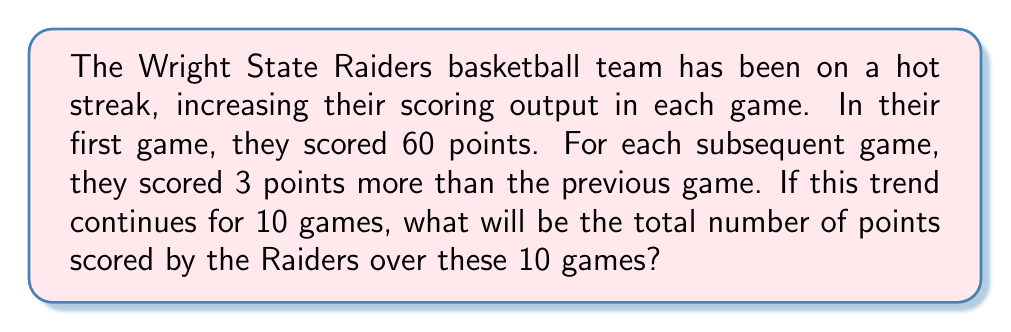Help me with this question. Let's approach this step-by-step using arithmetic sequences and series:

1) First, we identify that this is an arithmetic sequence with:
   - First term, $a_1 = 60$
   - Common difference, $d = 3$
   - Number of terms, $n = 10$

2) The arithmetic sequence formula is:
   $a_n = a_1 + (n-1)d$

3) We can find the 10th game score:
   $a_{10} = 60 + (10-1)3 = 60 + 27 = 87$

4) To find the total points, we need to sum this arithmetic sequence. The formula for the sum of an arithmetic sequence is:
   $$S_n = \frac{n}{2}(a_1 + a_n)$$

5) We know $n = 10$, $a_1 = 60$, and we calculated $a_{10} = 87$. Let's substitute:
   $$S_{10} = \frac{10}{2}(60 + 87)$$

6) Simplify:
   $$S_{10} = 5(147) = 735$$

Therefore, the Raiders will score a total of 735 points over these 10 games.
Answer: 735 points 